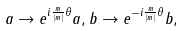Convert formula to latex. <formula><loc_0><loc_0><loc_500><loc_500>a \rightarrow e ^ { i \frac { m } { | m | } \theta } a , b \rightarrow e ^ { - i \frac { m } { | m | } \theta } b ,</formula> 